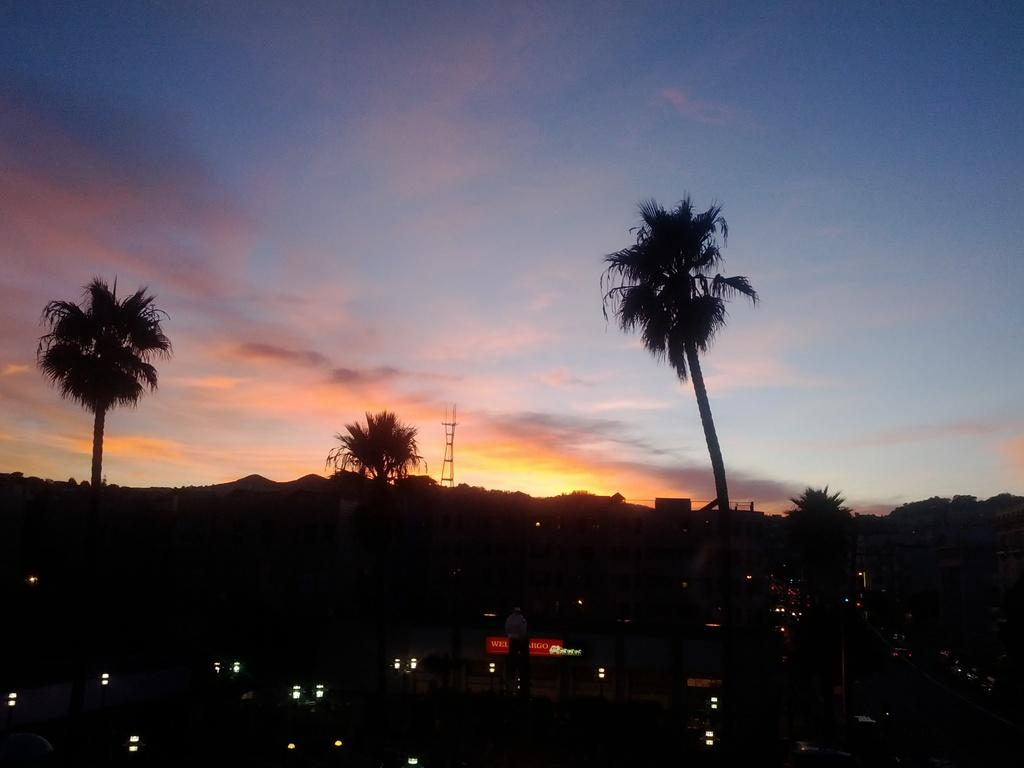What is the overall lighting condition in the image? The image is dark. Despite the darkness, what can be seen in the image? There are lights visible in the image. What type of natural elements are present in the image? There are trees in the image. What type of structure can be seen in the image? There is a tower in the image. What is visible in the background of the image? The sky with clouds is visible in the background of the image. What type of plant is being used for writing in the image? There is no plant being used for writing in the image. How many toes are visible on the tower in the image? There are no toes visible in the image, as it does not depict any human or animal body parts. 